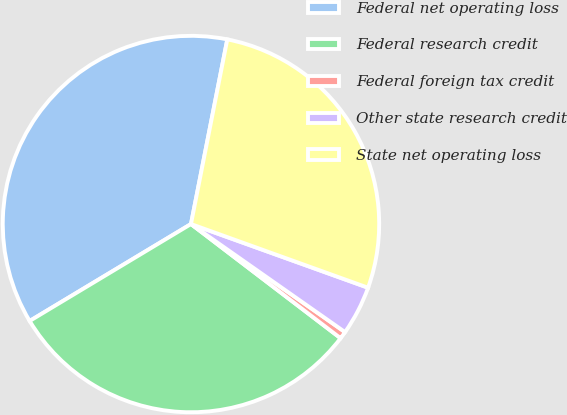Convert chart. <chart><loc_0><loc_0><loc_500><loc_500><pie_chart><fcel>Federal net operating loss<fcel>Federal research credit<fcel>Federal foreign tax credit<fcel>Other state research credit<fcel>State net operating loss<nl><fcel>36.7%<fcel>31.01%<fcel>0.64%<fcel>4.24%<fcel>27.4%<nl></chart> 